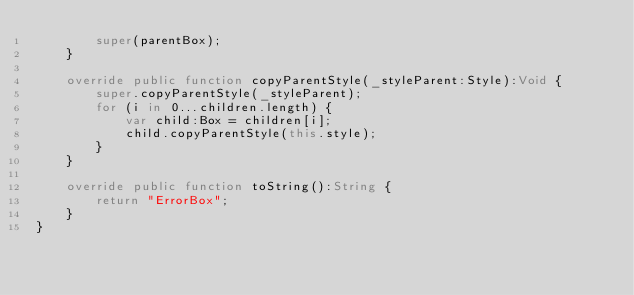Convert code to text. <code><loc_0><loc_0><loc_500><loc_500><_Haxe_>		super(parentBox);
	}
	
	override public function copyParentStyle(_styleParent:Style):Void {
		super.copyParentStyle(_styleParent);
		for (i in 0...children.length) {
			var child:Box = children[i];
			child.copyParentStyle(this.style);
		}
	}
	
	override public function toString():String {
		return "ErrorBox";
	}
}</code> 